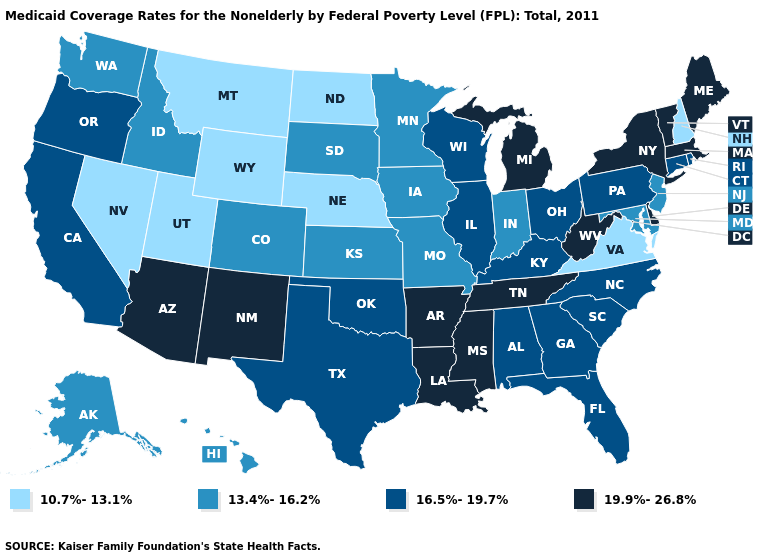What is the value of New Mexico?
Give a very brief answer. 19.9%-26.8%. Does the map have missing data?
Give a very brief answer. No. What is the value of Maryland?
Answer briefly. 13.4%-16.2%. Among the states that border Mississippi , which have the lowest value?
Quick response, please. Alabama. Does Kentucky have the highest value in the South?
Short answer required. No. Name the states that have a value in the range 13.4%-16.2%?
Concise answer only. Alaska, Colorado, Hawaii, Idaho, Indiana, Iowa, Kansas, Maryland, Minnesota, Missouri, New Jersey, South Dakota, Washington. Does Nebraska have the lowest value in the USA?
Quick response, please. Yes. Which states have the lowest value in the MidWest?
Be succinct. Nebraska, North Dakota. Does Florida have a higher value than Connecticut?
Quick response, please. No. Name the states that have a value in the range 10.7%-13.1%?
Write a very short answer. Montana, Nebraska, Nevada, New Hampshire, North Dakota, Utah, Virginia, Wyoming. Which states hav the highest value in the MidWest?
Concise answer only. Michigan. Name the states that have a value in the range 19.9%-26.8%?
Be succinct. Arizona, Arkansas, Delaware, Louisiana, Maine, Massachusetts, Michigan, Mississippi, New Mexico, New York, Tennessee, Vermont, West Virginia. Does North Dakota have a lower value than Nebraska?
Keep it brief. No. 